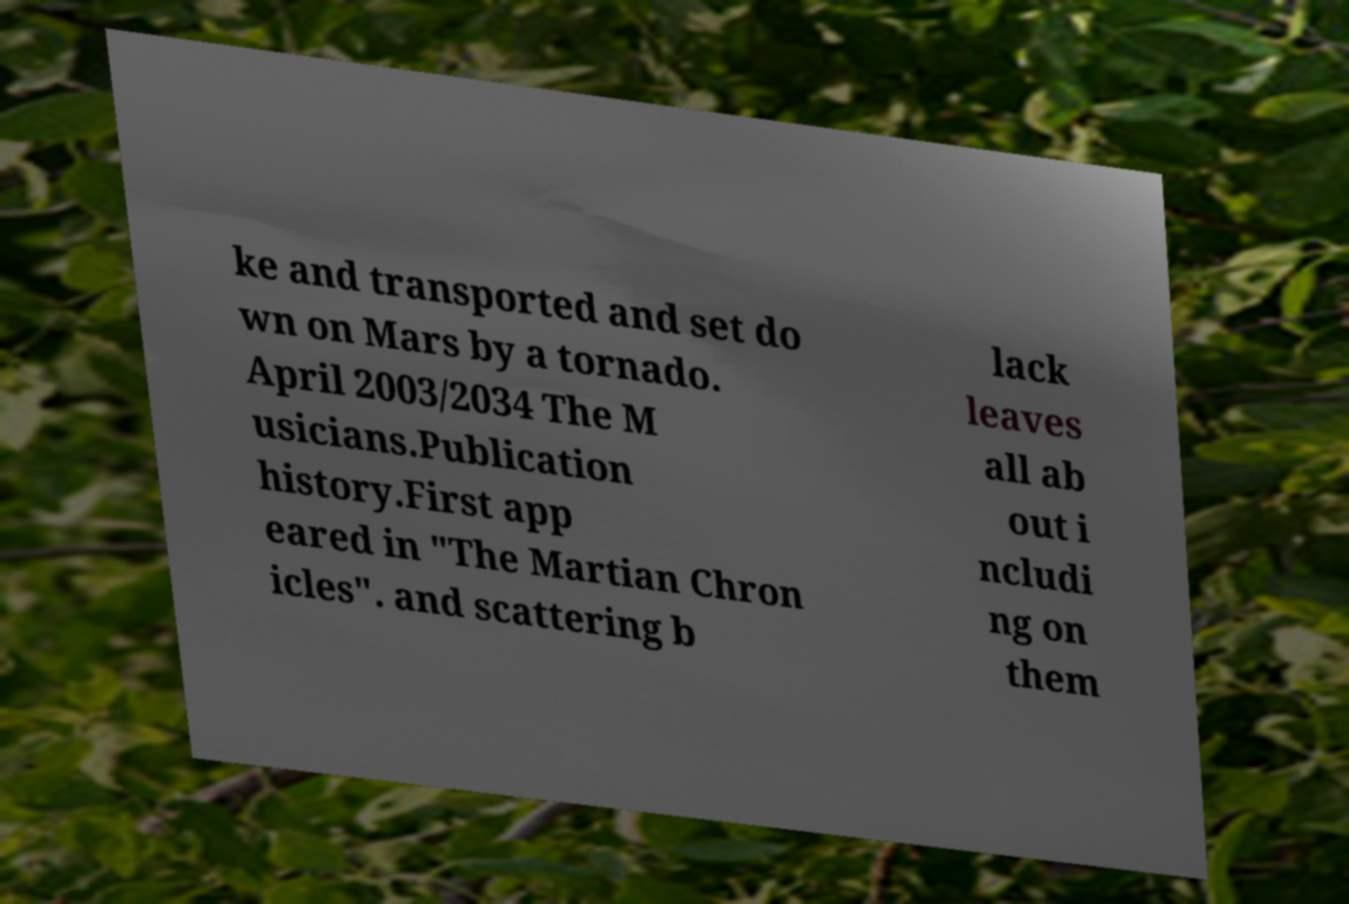Could you assist in decoding the text presented in this image and type it out clearly? ke and transported and set do wn on Mars by a tornado. April 2003/2034 The M usicians.Publication history.First app eared in "The Martian Chron icles". and scattering b lack leaves all ab out i ncludi ng on them 